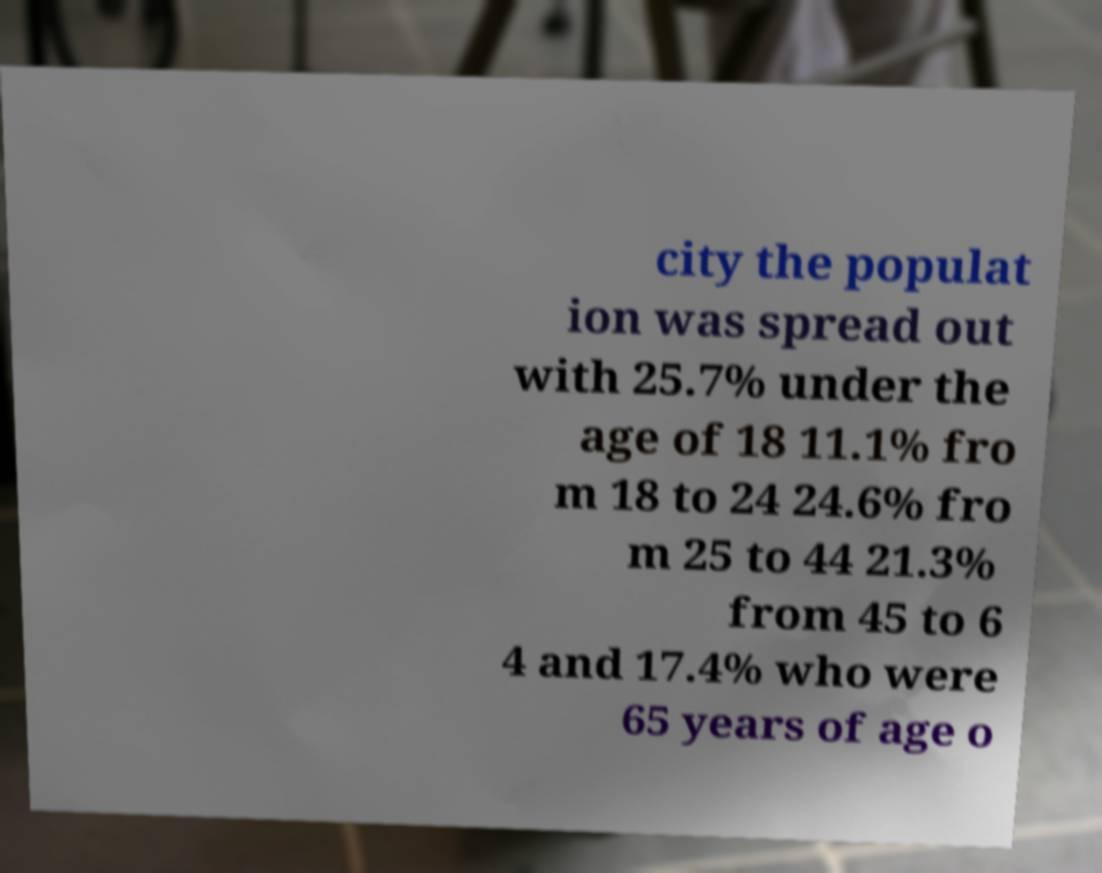Please read and relay the text visible in this image. What does it say? city the populat ion was spread out with 25.7% under the age of 18 11.1% fro m 18 to 24 24.6% fro m 25 to 44 21.3% from 45 to 6 4 and 17.4% who were 65 years of age o 